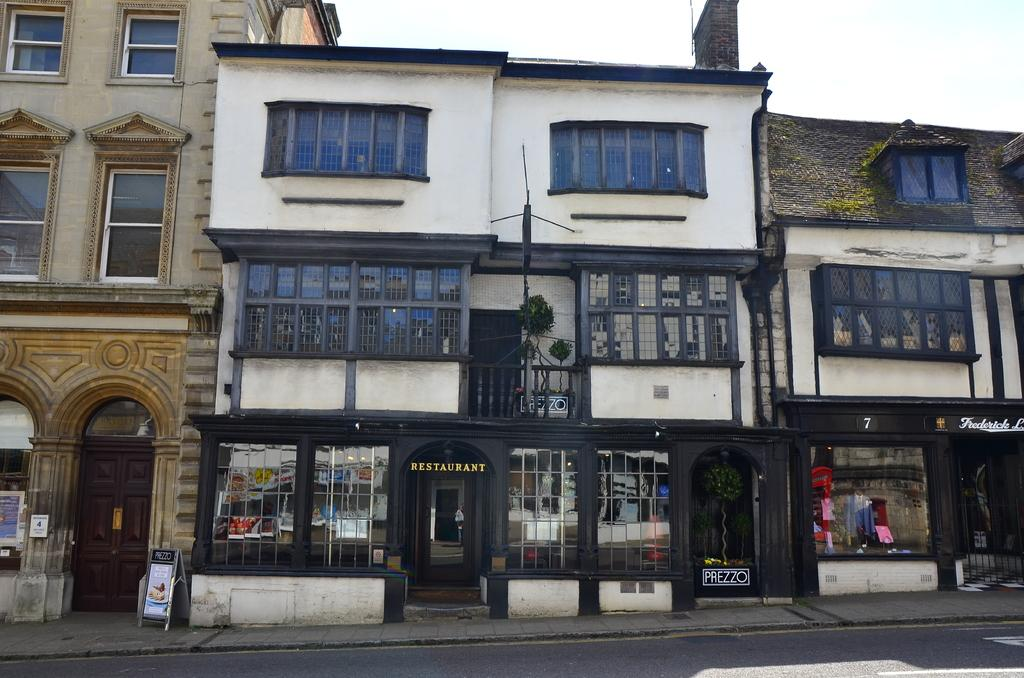What type of structures are present in the image? There are buildings in the image. What can be found on the sidewalk in the image? There is a board on the sidewalk in the image. How would you describe the sky in the image? The sky is cloudy in the image. What type of material is used for the windows on the buildings? There are glass windows visible on the buildings. What color is the sweater worn by the uncle in the image? There is no uncle or sweater present in the image. 